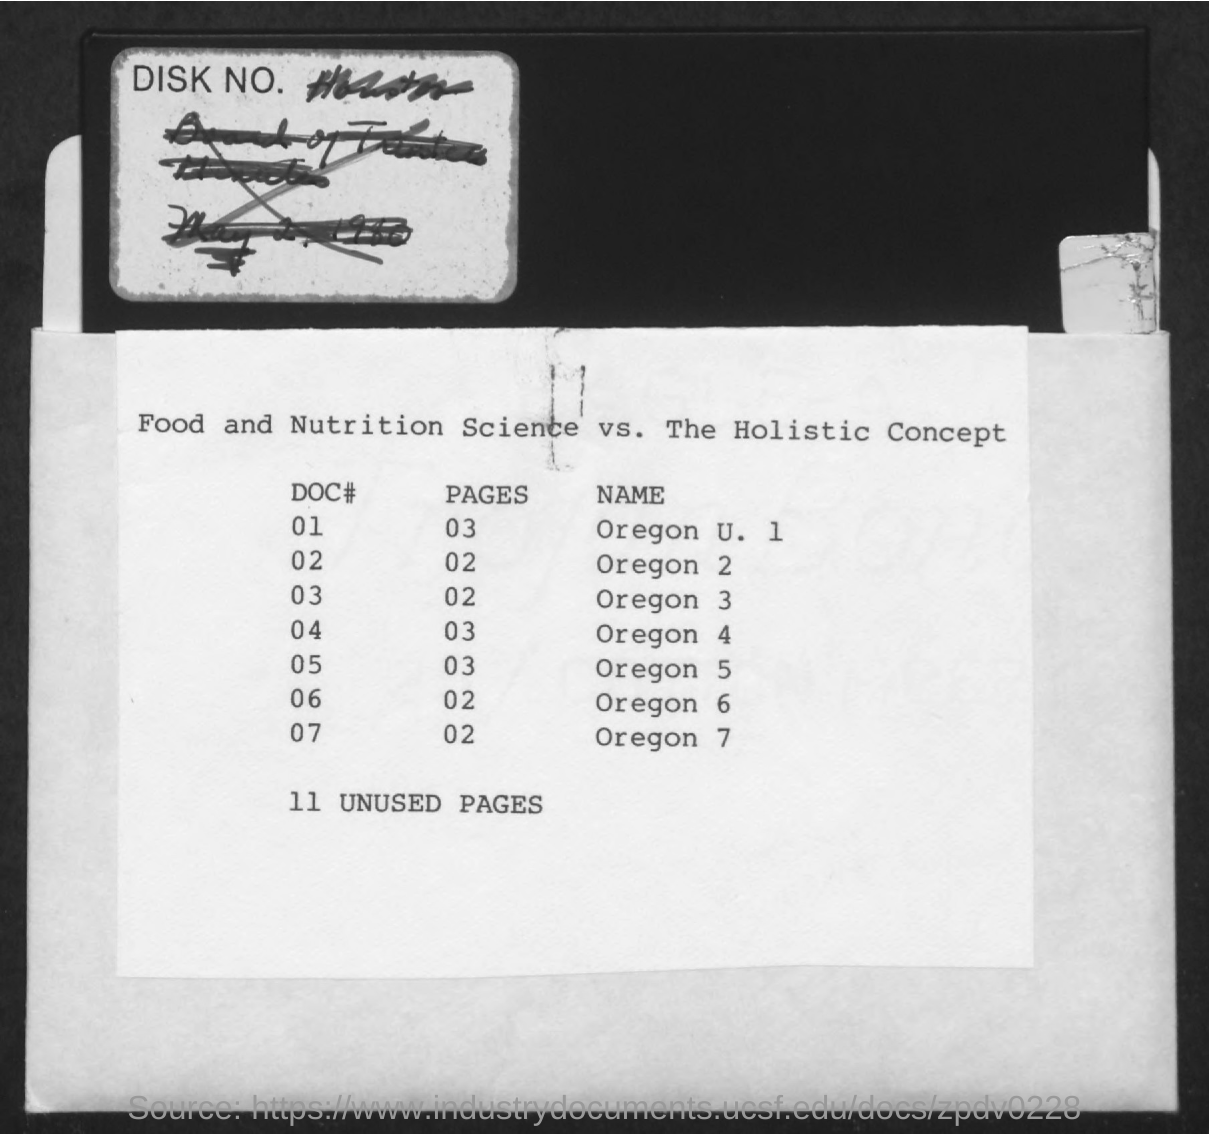Give some essential details in this illustration. The name "Oregon 7" is located on page 02. There are 11 unused pages. 